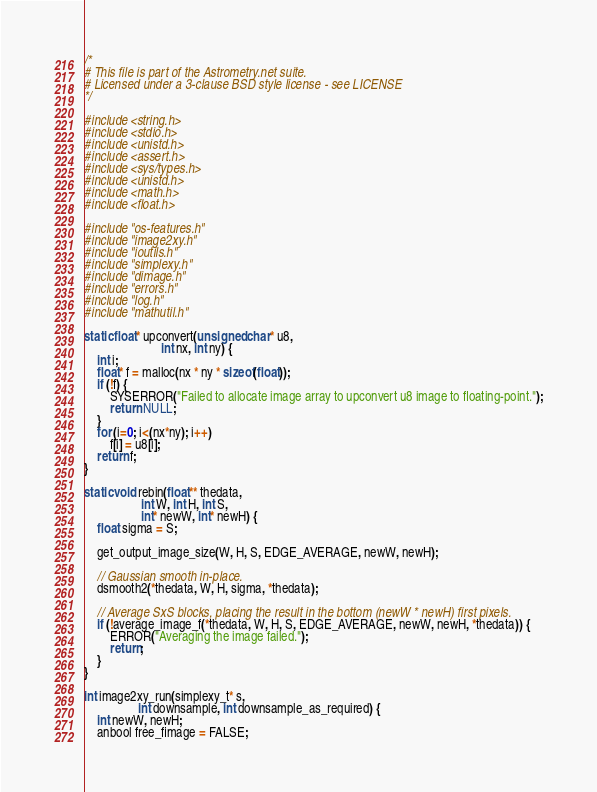Convert code to text. <code><loc_0><loc_0><loc_500><loc_500><_C_>/*
# This file is part of the Astrometry.net suite.
# Licensed under a 3-clause BSD style license - see LICENSE
*/

#include <string.h>
#include <stdio.h>
#include <unistd.h>
#include <assert.h>
#include <sys/types.h>
#include <unistd.h>
#include <math.h>
#include <float.h>

#include "os-features.h"
#include "image2xy.h"
#include "ioutils.h"
#include "simplexy.h"
#include "dimage.h"
#include "errors.h"
#include "log.h"
#include "mathutil.h"

static float* upconvert(unsigned char* u8,
                        int nx, int ny) {
    int i;
    float* f = malloc(nx * ny * sizeof(float));
    if (!f) {
        SYSERROR("Failed to allocate image array to upconvert u8 image to floating-point.");
        return NULL;
    }
    for (i=0; i<(nx*ny); i++)
        f[i] = u8[i];
    return f;
}

static void rebin(float** thedata,
                  int W, int H, int S,
                  int* newW, int* newH) {
    float sigma = S;

	get_output_image_size(W, H, S, EDGE_AVERAGE, newW, newH);

    // Gaussian smooth in-place.
    dsmooth2(*thedata, W, H, sigma, *thedata);

    // Average SxS blocks, placing the result in the bottom (newW * newH) first pixels.
	if (!average_image_f(*thedata, W, H, S, EDGE_AVERAGE, newW, newH, *thedata)) {
		ERROR("Averaging the image failed.");
		return;
	}
}

int image2xy_run(simplexy_t* s,
				 int downsample, int downsample_as_required) {
	int newW, newH;
	anbool free_fimage = FALSE;</code> 